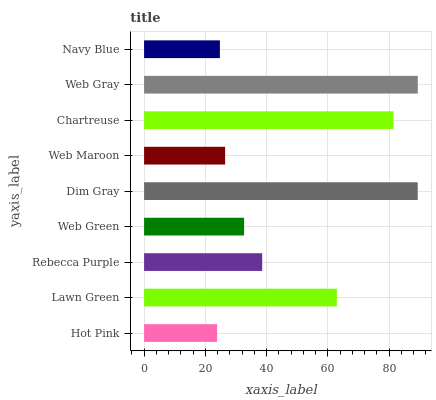Is Hot Pink the minimum?
Answer yes or no. Yes. Is Web Gray the maximum?
Answer yes or no. Yes. Is Lawn Green the minimum?
Answer yes or no. No. Is Lawn Green the maximum?
Answer yes or no. No. Is Lawn Green greater than Hot Pink?
Answer yes or no. Yes. Is Hot Pink less than Lawn Green?
Answer yes or no. Yes. Is Hot Pink greater than Lawn Green?
Answer yes or no. No. Is Lawn Green less than Hot Pink?
Answer yes or no. No. Is Rebecca Purple the high median?
Answer yes or no. Yes. Is Rebecca Purple the low median?
Answer yes or no. Yes. Is Web Gray the high median?
Answer yes or no. No. Is Navy Blue the low median?
Answer yes or no. No. 